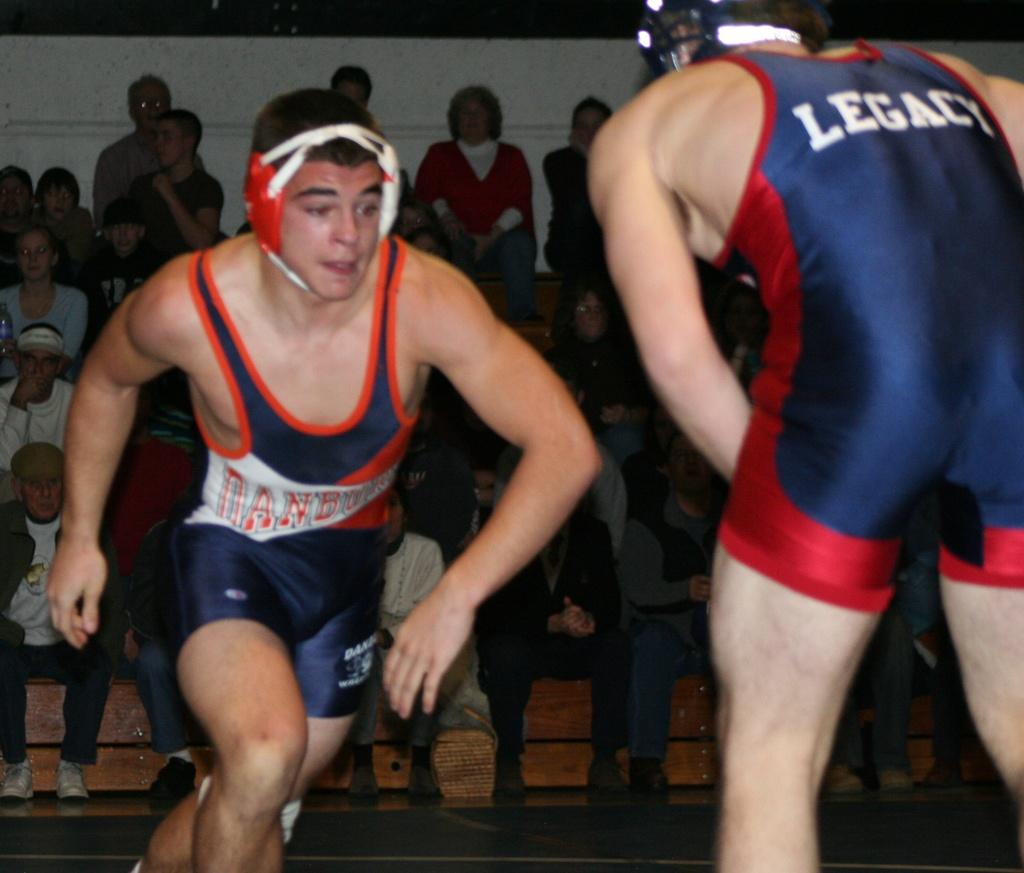<image>
Create a compact narrative representing the image presented. A few male wrestlers are together on the platform and one has a LEGACY uniform on. 